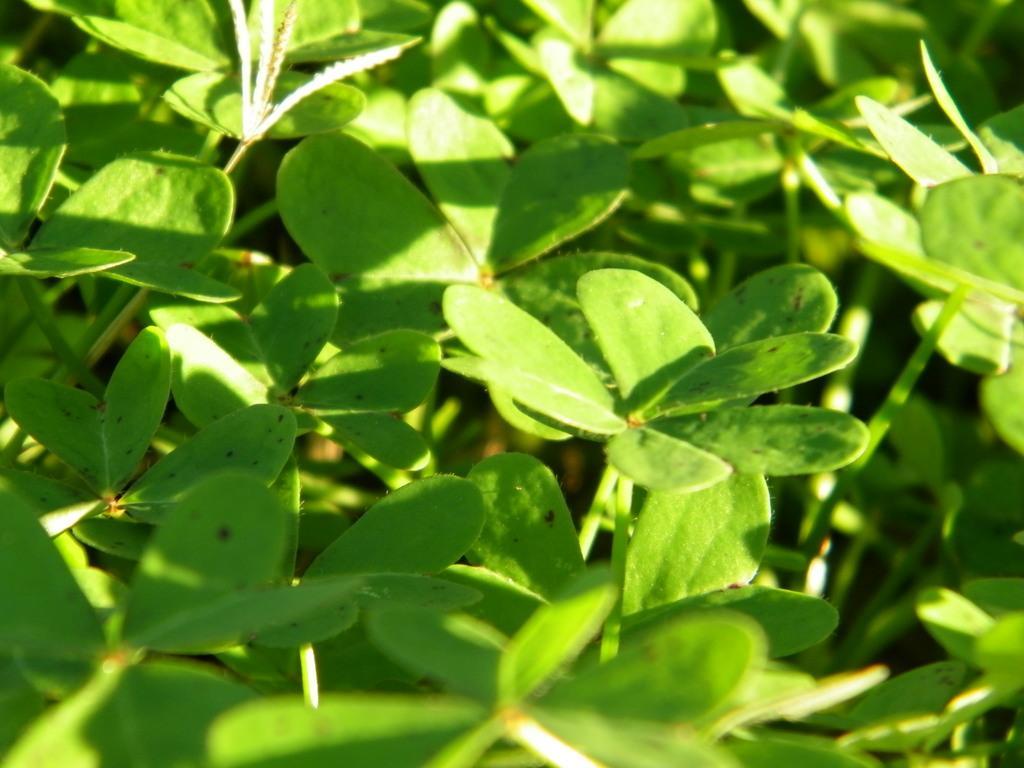Describe this image in one or two sentences. In this image, we can that there are some green plants. 